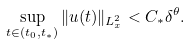Convert formula to latex. <formula><loc_0><loc_0><loc_500><loc_500>\sup _ { t \in ( t _ { 0 } , t _ { * } ) } \| u ( t ) \| _ { L ^ { 2 } _ { x } } < C _ { * } \delta ^ { \theta } .</formula> 